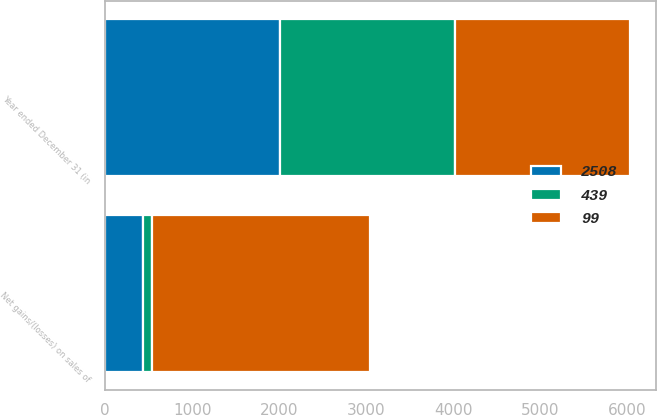<chart> <loc_0><loc_0><loc_500><loc_500><stacked_bar_chart><ecel><fcel>Year ended December 31 (in<fcel>Net gains/(losses) on sales of<nl><fcel>2508<fcel>2009<fcel>439<nl><fcel>99<fcel>2008<fcel>2508<nl><fcel>439<fcel>2007<fcel>99<nl></chart> 